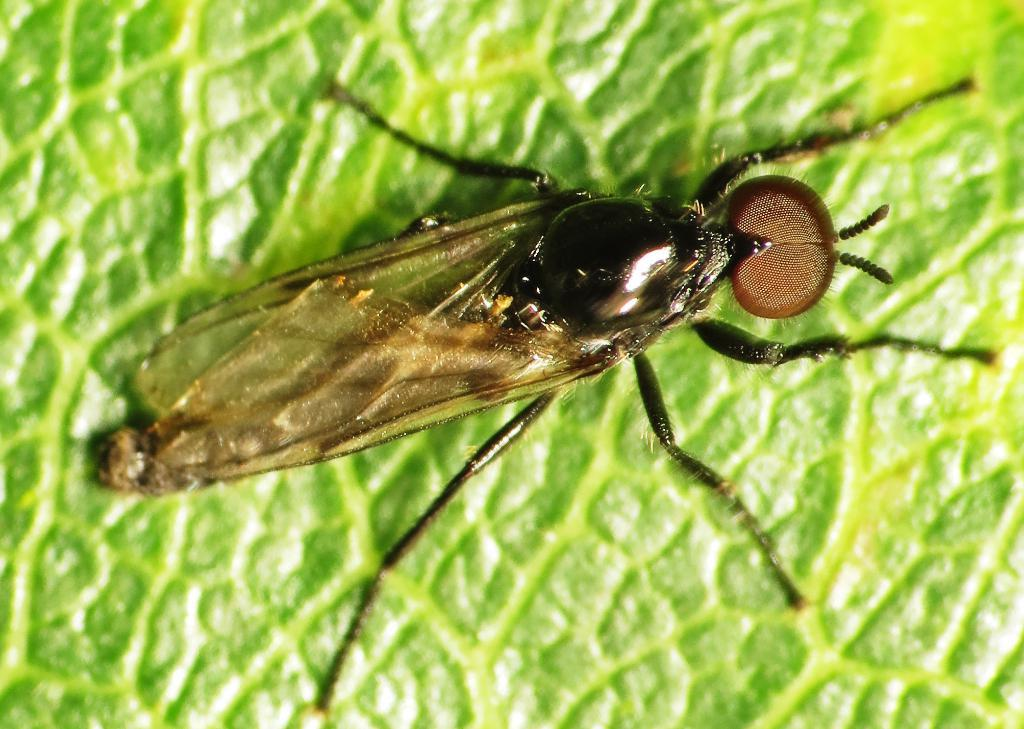What is the focus of the image? The image is zoomed in on an insect. Where is the insect located in the image? The insect is in the center of the image. What is the insect sitting on? The insect is on a green object, which appears to be a leaf of a plant. What type of nail is the beggar using to dig with a spade in the image? There is no nail, beggar, or spade present in the image; it features a zoomed-in view of an insect on a leaf. 